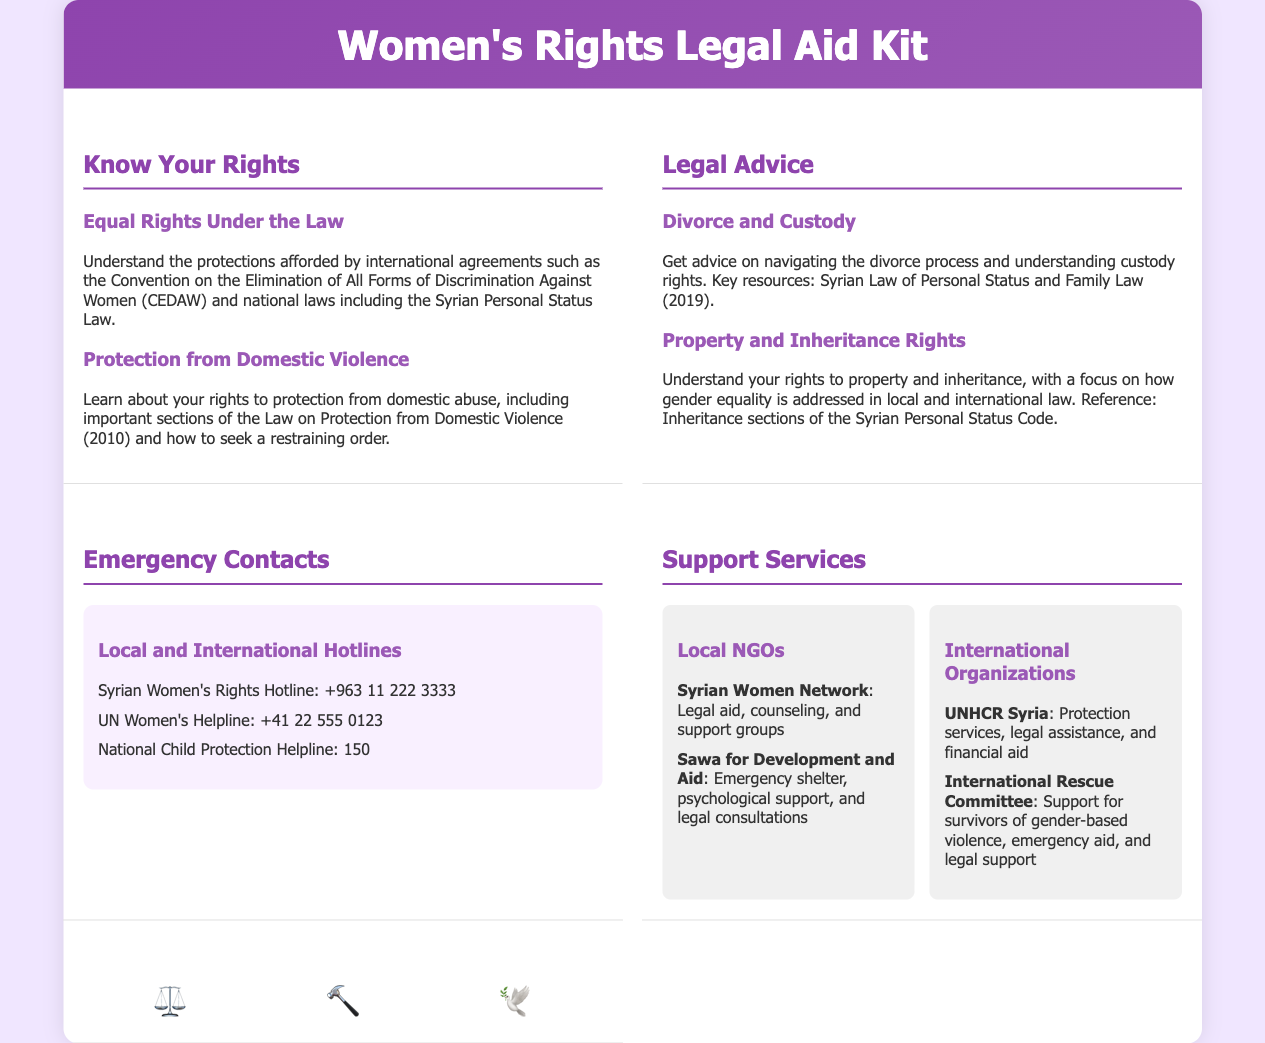What is the title of the kit? The title is prominently displayed in the header section of the document.
Answer: Women's Rights Legal Aid Kit What hotline number is for the Syrian Women's Rights Hotline? The emergency contacts section lists the hotline numbers available for immediate assistance.
Answer: +963 11 222 3333 Which legal document is referenced for divorce and custody advice? The legal advice section provides sources for understanding rights regarding family law.
Answer: Syrian Law of Personal Status and Family Law (2019) What year was the Law on Protection from Domestic Violence enacted? The document provides specific information regarding laws protecting individuals from domestic violence.
Answer: 2010 How many symbols are displayed in the footer? The footer section outlines the visual representation used to symbolize justice and women's rights.
Answer: 3 What type of services does the Syrian Women Network provide? The support services section lists the services offered by local NGOs.
Answer: Legal aid, counseling, and support groups What does the symbol ⚖️ represent in the document? The symbols are used to convey empowering messages related to justice.
Answer: Justice What is the purpose of the Women's Rights Legal Aid Kit? The overall objective of the kit is defined in its title and introductory sections.
Answer: Legal aid and support for women’s rights 